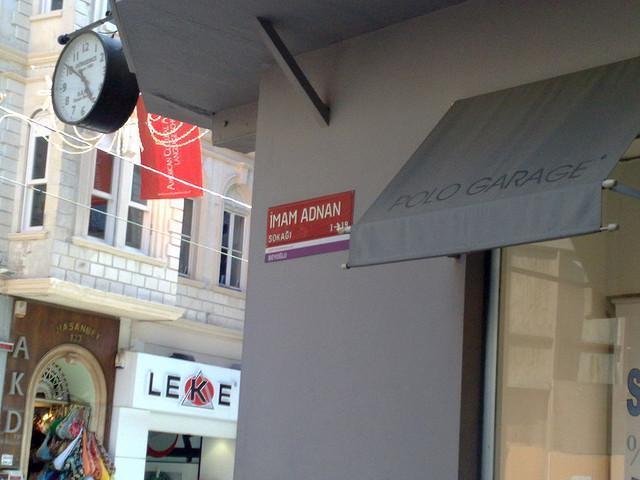How many clocks are shaped like a triangle?
Give a very brief answer. 0. How many toilets are there?
Give a very brief answer. 0. 